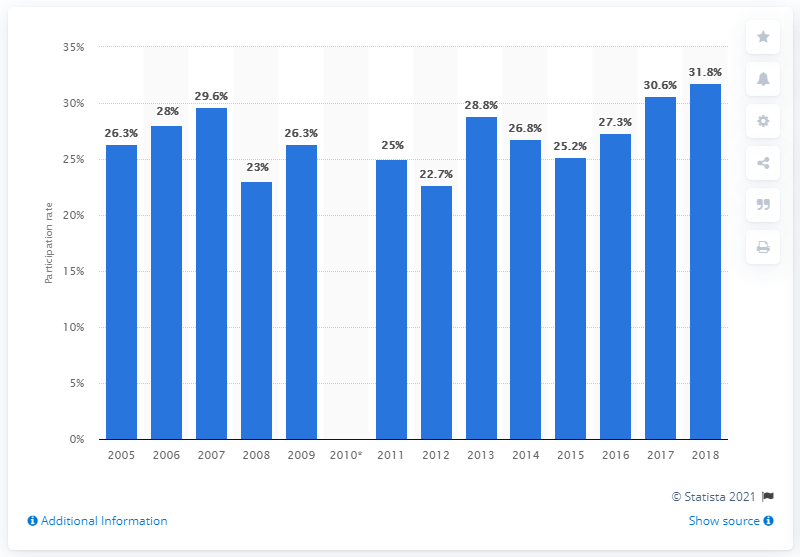Specify some key components in this picture. In 2018, it is estimated that approximately 31.8% of the UK population participated in watersports. 